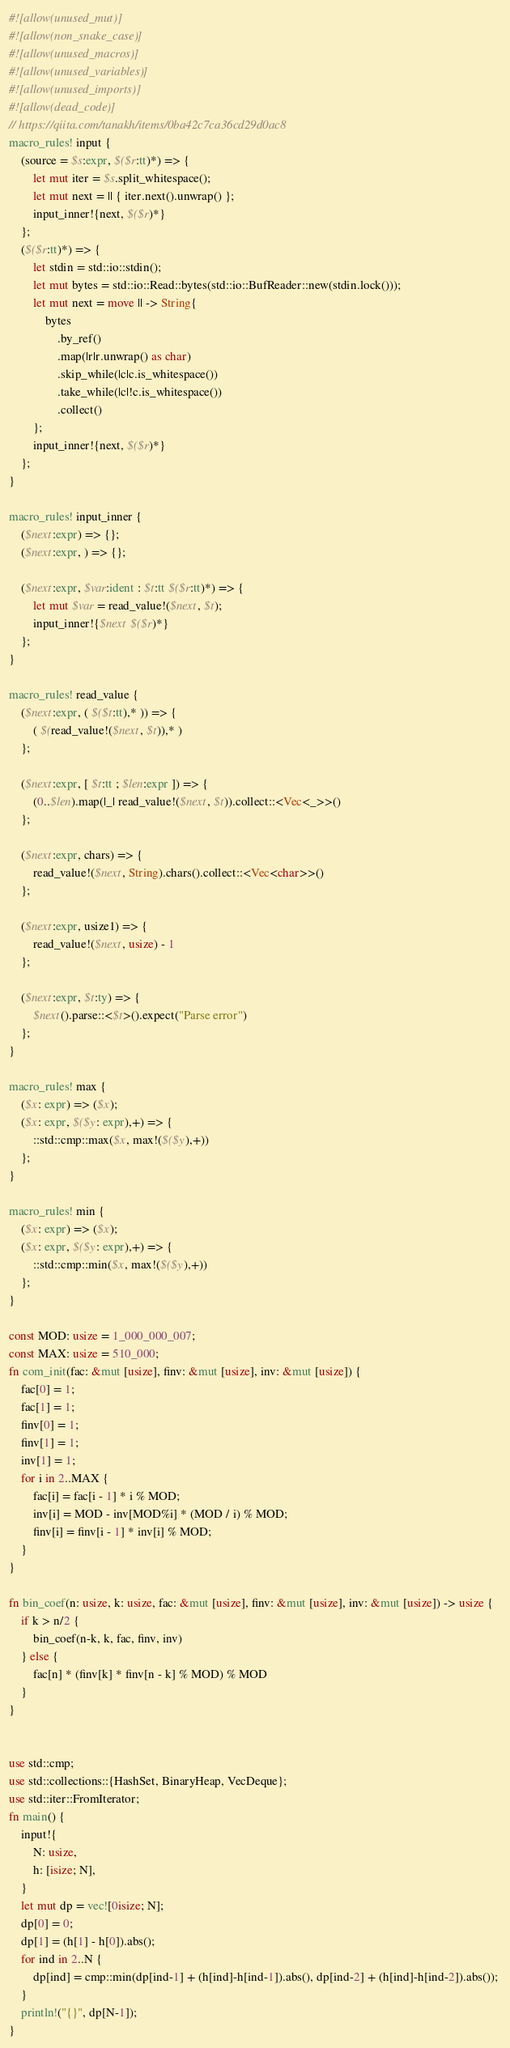Convert code to text. <code><loc_0><loc_0><loc_500><loc_500><_Rust_>#![allow(unused_mut)]
#![allow(non_snake_case)]
#![allow(unused_macros)]
#![allow(unused_variables)]
#![allow(unused_imports)]
#![allow(dead_code)]
// https://qiita.com/tanakh/items/0ba42c7ca36cd29d0ac8
macro_rules! input {
    (source = $s:expr, $($r:tt)*) => {
        let mut iter = $s.split_whitespace();
        let mut next = || { iter.next().unwrap() };
        input_inner!{next, $($r)*}
    };
    ($($r:tt)*) => {
        let stdin = std::io::stdin();
        let mut bytes = std::io::Read::bytes(std::io::BufReader::new(stdin.lock()));
        let mut next = move || -> String{
            bytes
                .by_ref()
                .map(|r|r.unwrap() as char)
                .skip_while(|c|c.is_whitespace())
                .take_while(|c|!c.is_whitespace())
                .collect()
        };
        input_inner!{next, $($r)*}
    };
}

macro_rules! input_inner {
    ($next:expr) => {};
    ($next:expr, ) => {};

    ($next:expr, $var:ident : $t:tt $($r:tt)*) => {
        let mut $var = read_value!($next, $t);
        input_inner!{$next $($r)*}
    };
}

macro_rules! read_value {
    ($next:expr, ( $($t:tt),* )) => {
        ( $(read_value!($next, $t)),* )
    };

    ($next:expr, [ $t:tt ; $len:expr ]) => {
        (0..$len).map(|_| read_value!($next, $t)).collect::<Vec<_>>()
    };

    ($next:expr, chars) => {
        read_value!($next, String).chars().collect::<Vec<char>>()
    };

    ($next:expr, usize1) => {
        read_value!($next, usize) - 1
    };

    ($next:expr, $t:ty) => {
        $next().parse::<$t>().expect("Parse error")
    };
}

macro_rules! max {
    ($x: expr) => ($x);
    ($x: expr, $($y: expr),+) => {
        ::std::cmp::max($x, max!($($y),+))
    };
}

macro_rules! min {
    ($x: expr) => ($x);
    ($x: expr, $($y: expr),+) => {
        ::std::cmp::min($x, max!($($y),+))
    };
}

const MOD: usize = 1_000_000_007;
const MAX: usize = 510_000;
fn com_init(fac: &mut [usize], finv: &mut [usize], inv: &mut [usize]) {
    fac[0] = 1;
    fac[1] = 1;
    finv[0] = 1;
    finv[1] = 1;
    inv[1] = 1;
    for i in 2..MAX {
        fac[i] = fac[i - 1] * i % MOD;
        inv[i] = MOD - inv[MOD%i] * (MOD / i) % MOD;
        finv[i] = finv[i - 1] * inv[i] % MOD;
    }
}

fn bin_coef(n: usize, k: usize, fac: &mut [usize], finv: &mut [usize], inv: &mut [usize]) -> usize {
    if k > n/2 {
        bin_coef(n-k, k, fac, finv, inv)
    } else {
        fac[n] * (finv[k] * finv[n - k] % MOD) % MOD
    }
}


use std::cmp;
use std::collections::{HashSet, BinaryHeap, VecDeque};
use std::iter::FromIterator;
fn main() {
    input!{
        N: usize,
        h: [isize; N],
    }
    let mut dp = vec![0isize; N];
    dp[0] = 0;
    dp[1] = (h[1] - h[0]).abs();
    for ind in 2..N {
        dp[ind] = cmp::min(dp[ind-1] + (h[ind]-h[ind-1]).abs(), dp[ind-2] + (h[ind]-h[ind-2]).abs()); 
    }
    println!("{}", dp[N-1]);
}
</code> 